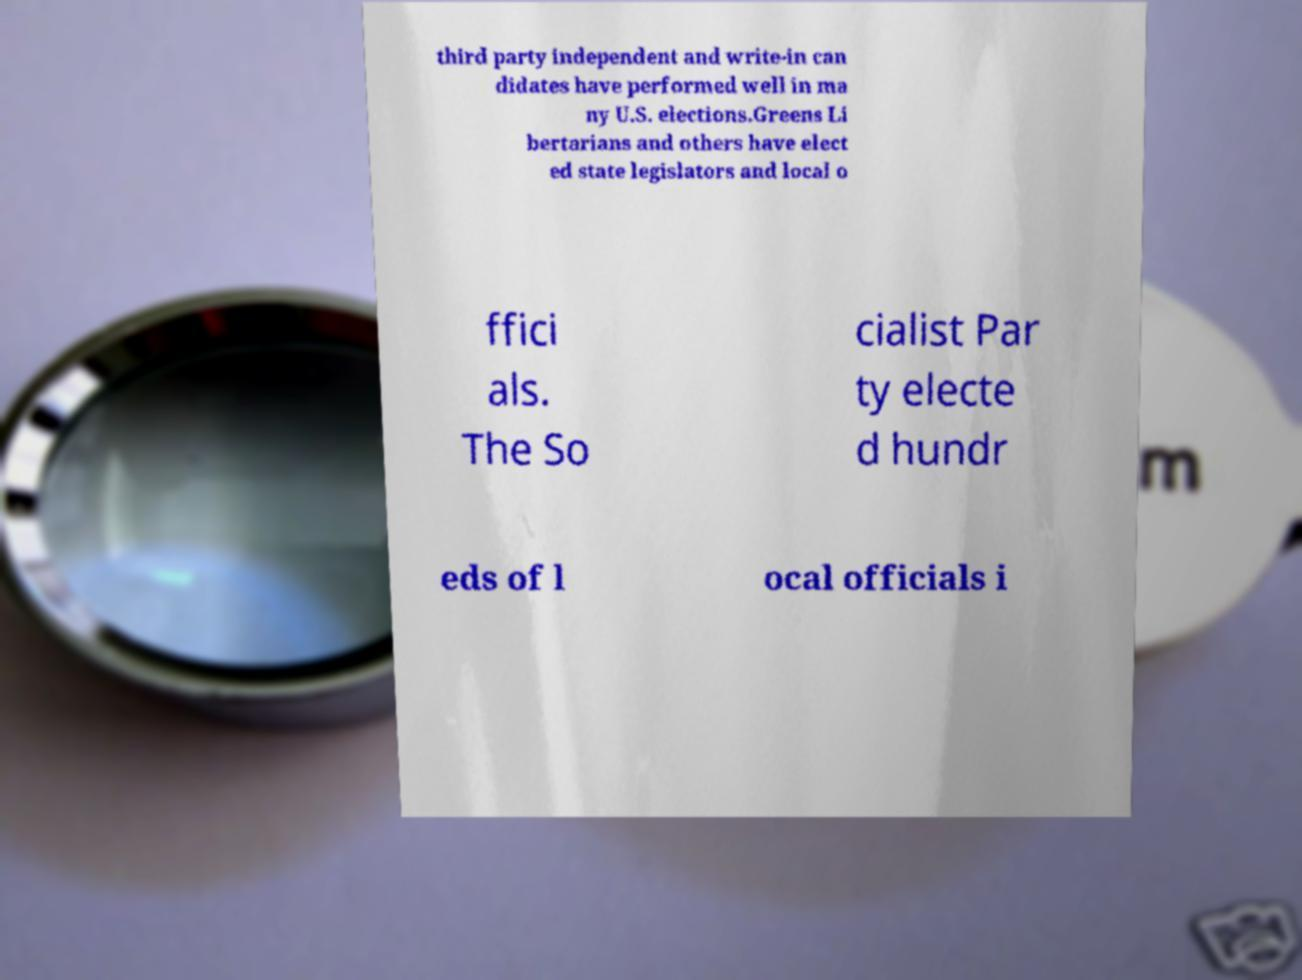I need the written content from this picture converted into text. Can you do that? third party independent and write-in can didates have performed well in ma ny U.S. elections.Greens Li bertarians and others have elect ed state legislators and local o ffici als. The So cialist Par ty electe d hundr eds of l ocal officials i 